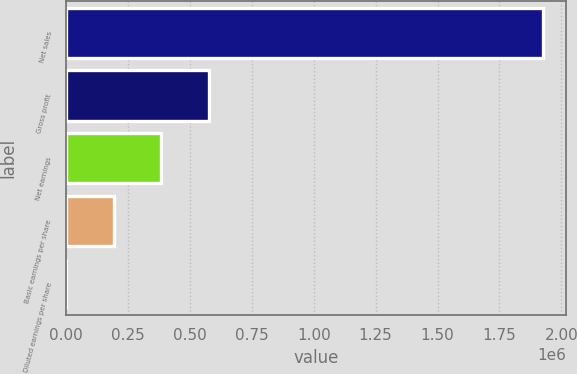Convert chart to OTSL. <chart><loc_0><loc_0><loc_500><loc_500><bar_chart><fcel>Net sales<fcel>Gross profit<fcel>Net earnings<fcel>Basic earnings per share<fcel>Diluted earnings per share<nl><fcel>1.9241e+06<fcel>577232<fcel>384822<fcel>192412<fcel>1.29<nl></chart> 